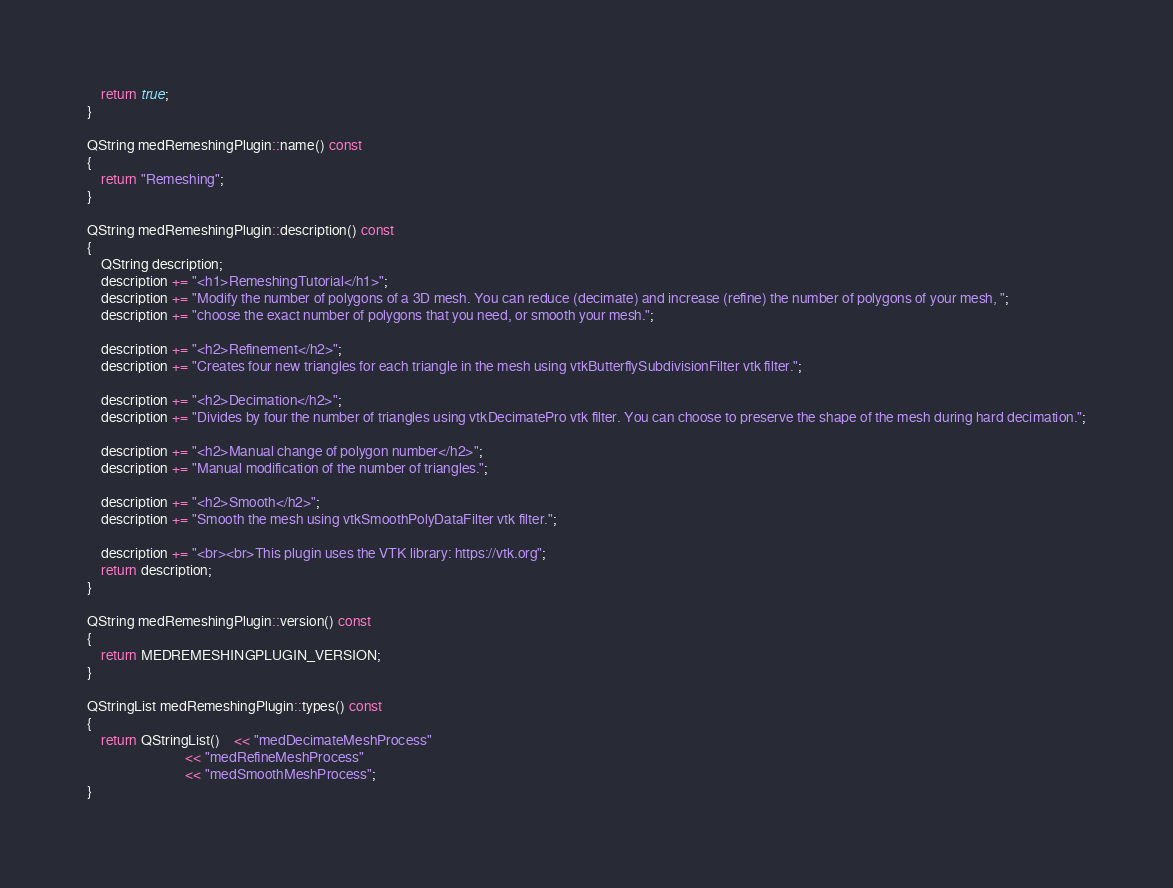<code> <loc_0><loc_0><loc_500><loc_500><_C++_>    return true;
}

QString medRemeshingPlugin::name() const
{
    return "Remeshing";
}

QString medRemeshingPlugin::description() const
{
    QString description;
    description += "<h1>RemeshingTutorial</h1>";
    description += "Modify the number of polygons of a 3D mesh. You can reduce (decimate) and increase (refine) the number of polygons of your mesh, ";
    description += "choose the exact number of polygons that you need, or smooth your mesh.";
    
    description += "<h2>Refinement</h2>";
    description += "Creates four new triangles for each triangle in the mesh using vtkButterflySubdivisionFilter vtk filter.";

    description += "<h2>Decimation</h2>";
    description += "Divides by four the number of triangles using vtkDecimatePro vtk filter. You can choose to preserve the shape of the mesh during hard decimation.";

    description += "<h2>Manual change of polygon number</h2>";
    description += "Manual modification of the number of triangles.";

    description += "<h2>Smooth</h2>";
    description += "Smooth the mesh using vtkSmoothPolyDataFilter vtk filter.";
 
    description += "<br><br>This plugin uses the VTK library: https://vtk.org";
    return description;
}

QString medRemeshingPlugin::version() const
{
    return MEDREMESHINGPLUGIN_VERSION;
}

QStringList medRemeshingPlugin::types() const
{
    return QStringList()    << "medDecimateMeshProcess"
                            << "medRefineMeshProcess"
                            << "medSmoothMeshProcess";
}
</code> 